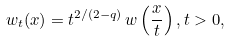Convert formula to latex. <formula><loc_0><loc_0><loc_500><loc_500>w _ { t } ( x ) = t ^ { 2 / ( 2 - q ) } \, w \left ( \frac { x } { t } \right ) , t > 0 ,</formula> 